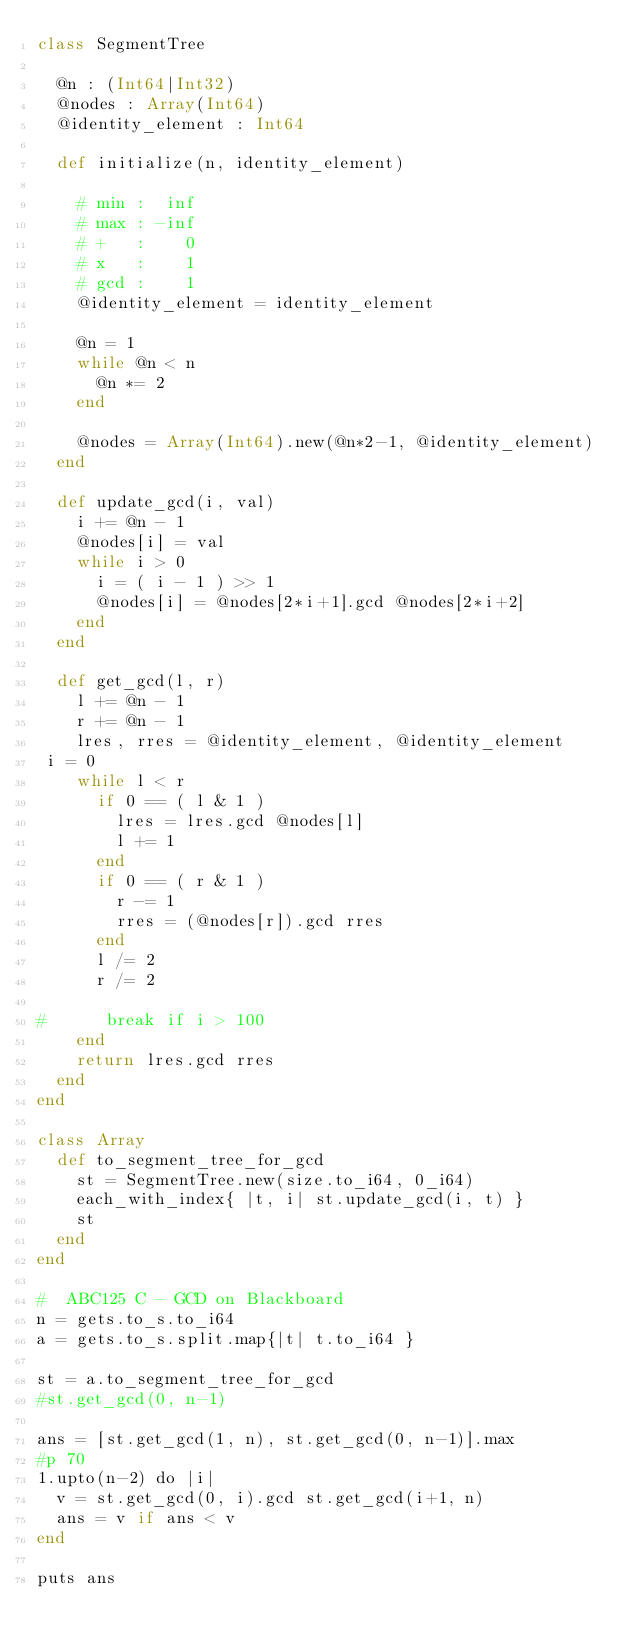Convert code to text. <code><loc_0><loc_0><loc_500><loc_500><_Crystal_>class SegmentTree
  
  @n : (Int64|Int32)
  @nodes : Array(Int64)
  @identity_element : Int64
  
  def initialize(n, identity_element)
    
    # min :  inf
    # max : -inf
    # +   :    0
    # x   :    1
    # gcd :    1
    @identity_element = identity_element
    
    @n = 1
    while @n < n
      @n *= 2
    end
    
    @nodes = Array(Int64).new(@n*2-1, @identity_element)
  end
  
  def update_gcd(i, val)
    i += @n - 1
    @nodes[i] = val
    while i > 0
      i = ( i - 1 ) >> 1
      @nodes[i] = @nodes[2*i+1].gcd @nodes[2*i+2]
    end
  end

  def get_gcd(l, r)
    l += @n - 1
    r += @n - 1
    lres, rres = @identity_element, @identity_element
 i = 0
    while l < r
      if 0 == ( l & 1 )
        lres = lres.gcd @nodes[l]
        l += 1
      end
      if 0 == ( r & 1 )
        r -= 1
        rres = (@nodes[r]).gcd rres
      end
      l /= 2
      r /= 2

#      break if i > 100
    end
    return lres.gcd rres
  end
end

class Array
  def to_segment_tree_for_gcd
    st = SegmentTree.new(size.to_i64, 0_i64)
    each_with_index{ |t, i| st.update_gcd(i, t) }
    st
  end
end

#  ABC125 C - GCD on Blackboard
n = gets.to_s.to_i64
a = gets.to_s.split.map{|t| t.to_i64 }

st = a.to_segment_tree_for_gcd
#st.get_gcd(0, n-1)

ans = [st.get_gcd(1, n), st.get_gcd(0, n-1)].max
#p 70
1.upto(n-2) do |i|
  v = st.get_gcd(0, i).gcd st.get_gcd(i+1, n) 
  ans = v if ans < v
end

puts ans
</code> 